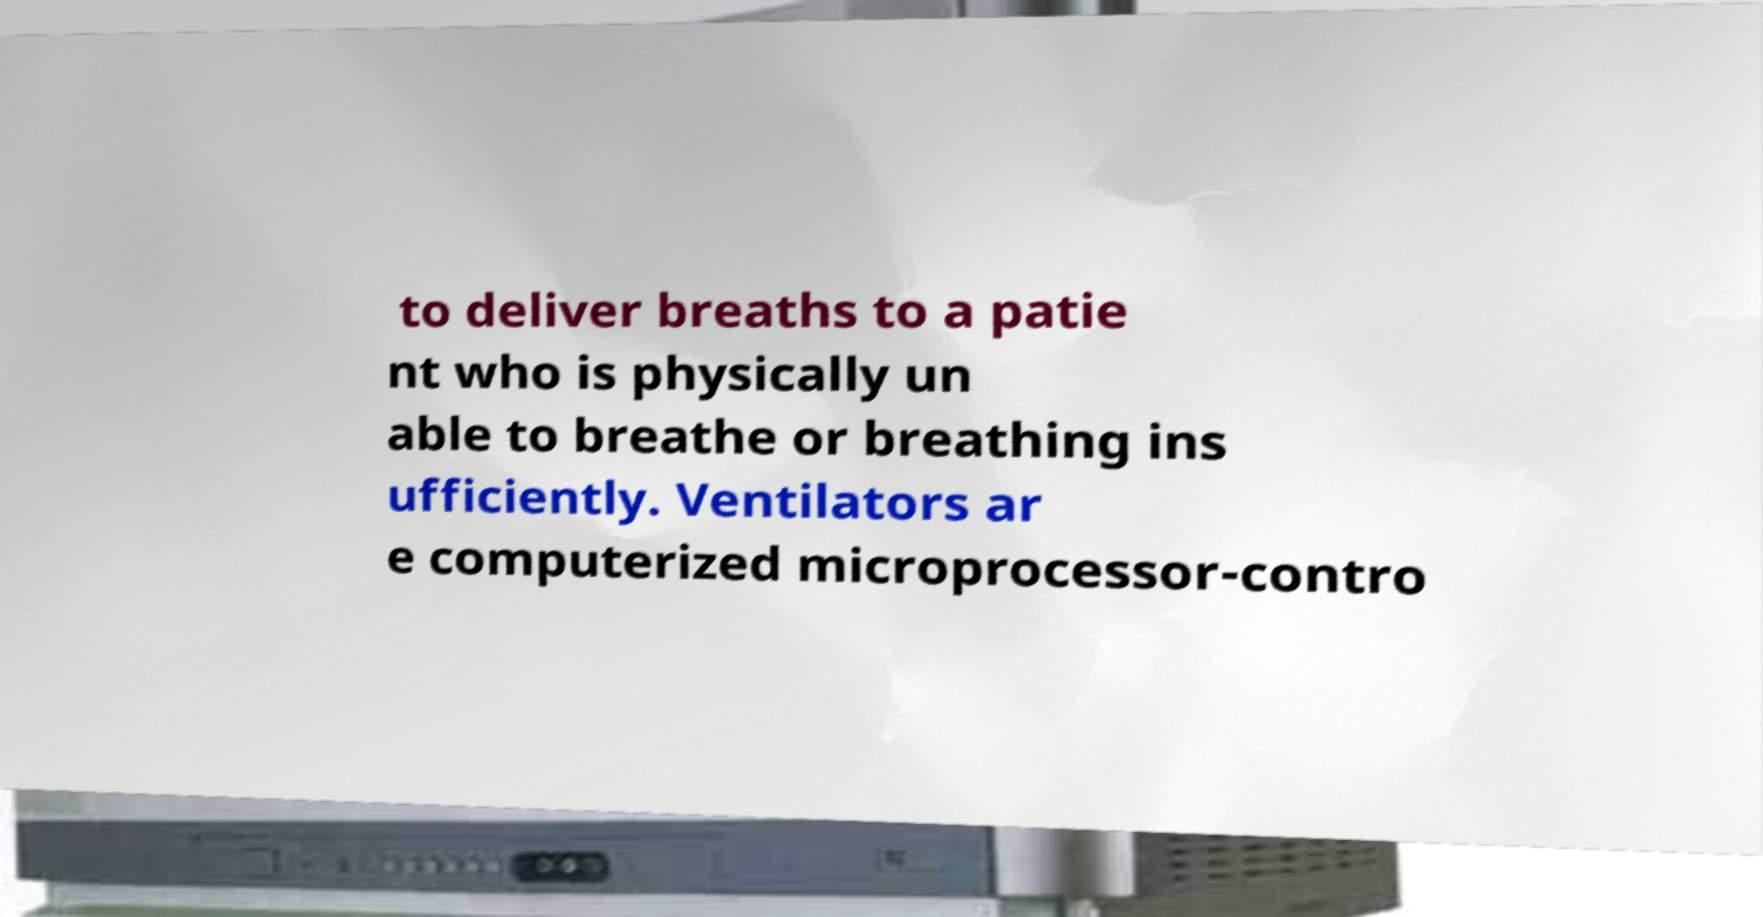There's text embedded in this image that I need extracted. Can you transcribe it verbatim? to deliver breaths to a patie nt who is physically un able to breathe or breathing ins ufficiently. Ventilators ar e computerized microprocessor-contro 